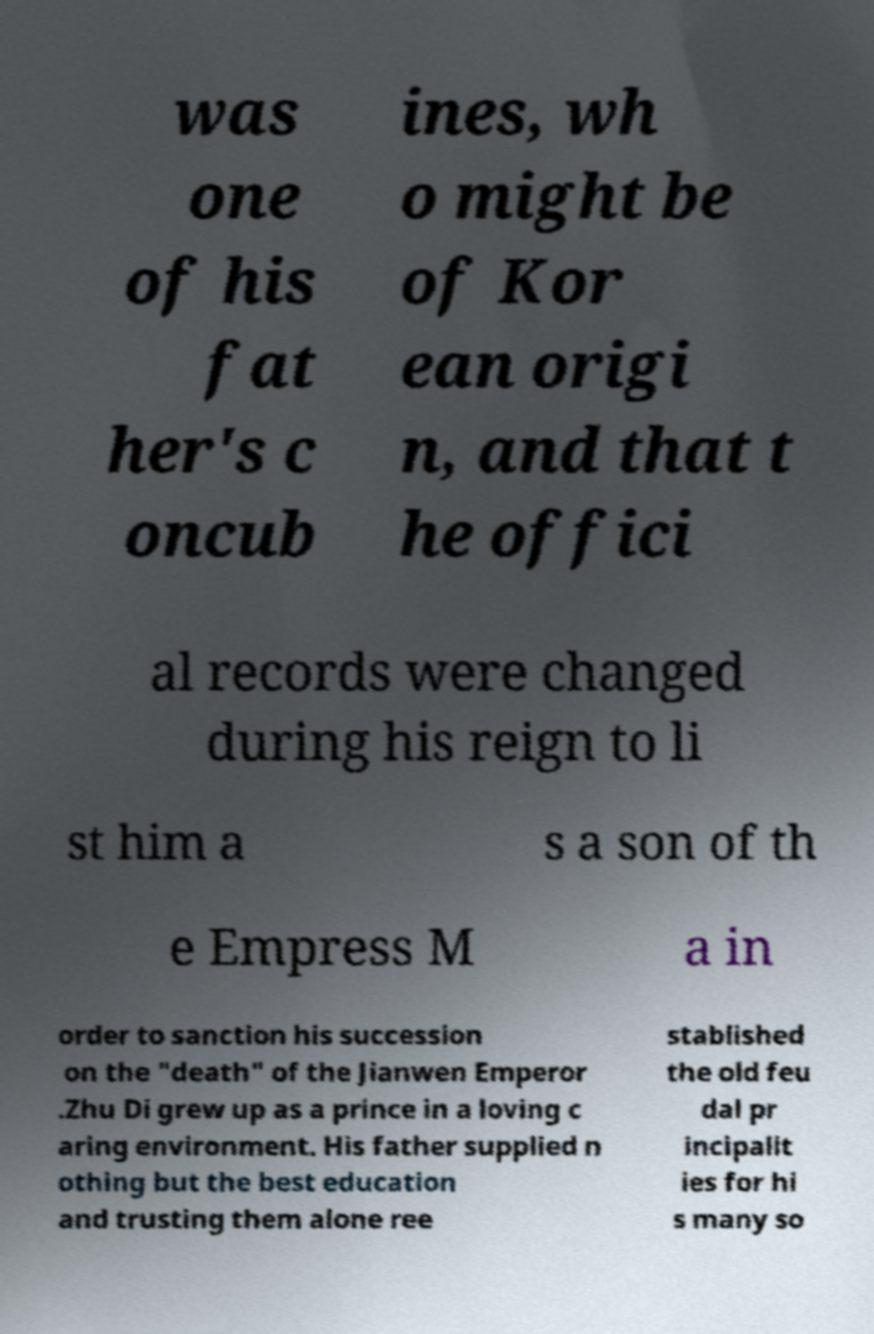What messages or text are displayed in this image? I need them in a readable, typed format. was one of his fat her's c oncub ines, wh o might be of Kor ean origi n, and that t he offici al records were changed during his reign to li st him a s a son of th e Empress M a in order to sanction his succession on the "death" of the Jianwen Emperor .Zhu Di grew up as a prince in a loving c aring environment. His father supplied n othing but the best education and trusting them alone ree stablished the old feu dal pr incipalit ies for hi s many so 